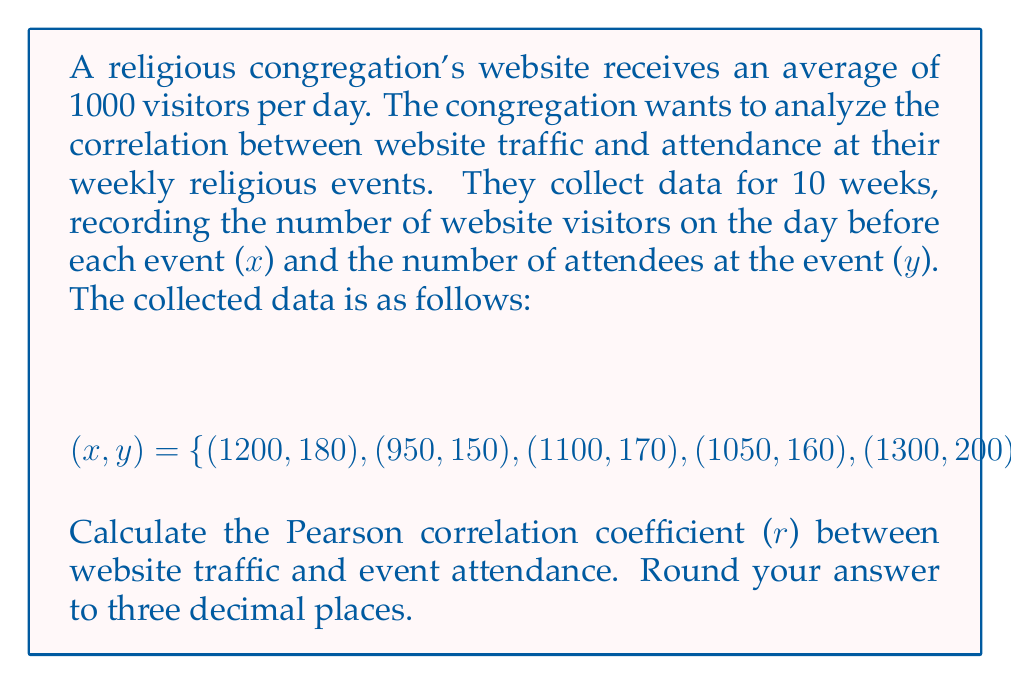Show me your answer to this math problem. To calculate the Pearson correlation coefficient (r), we'll use the formula:

$$r = \frac{\sum_{i=1}^{n} (x_i - \bar{x})(y_i - \bar{y})}{\sqrt{\sum_{i=1}^{n} (x_i - \bar{x})^2} \sqrt{\sum_{i=1}^{n} (y_i - \bar{y})^2}}$$

where $\bar{x}$ and $\bar{y}$ are the means of x and y respectively.

Step 1: Calculate the means
$\bar{x} = \frac{1200 + 950 + 1100 + 1050 + 1300 + 900 + 1150 + 1000 + 1250 + 1080}{10} = 1098$
$\bar{y} = \frac{180 + 150 + 170 + 160 + 200 + 140 + 175 + 155 + 190 + 165}{10} = 168.5$

Step 2: Calculate $(x_i - \bar{x})$, $(y_i - \bar{y})$, $(x_i - \bar{x})^2$, $(y_i - \bar{y})^2$, and $(x_i - \bar{x})(y_i - \bar{y})$ for each pair

Step 3: Sum up the calculated values
$\sum (x_i - \bar{x})(y_i - \bar{y}) = 16,225$
$\sum (x_i - \bar{x})^2 = 165,300$
$\sum (y_i - \bar{y})^2 = 2,462.5$

Step 4: Apply the formula
$$r = \frac{16,225}{\sqrt{165,300} \sqrt{2,462.5}} = \frac{16,225}{\sqrt{407,051,250}} = \frac{16,225}{20,175.61} \approx 0.804$$
Answer: The Pearson correlation coefficient (r) between website traffic and event attendance is approximately 0.804. 